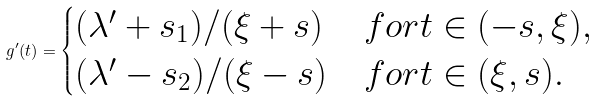<formula> <loc_0><loc_0><loc_500><loc_500>g ^ { \prime } ( t ) = \begin{cases} ( \lambda ^ { \prime } + s _ { 1 } ) / ( \xi + s ) & f o r t \in ( - s , \xi ) , \\ ( \lambda ^ { \prime } - s _ { 2 } ) / ( \xi - s ) & f o r t \in ( \xi , s ) . \\ \end{cases}</formula> 